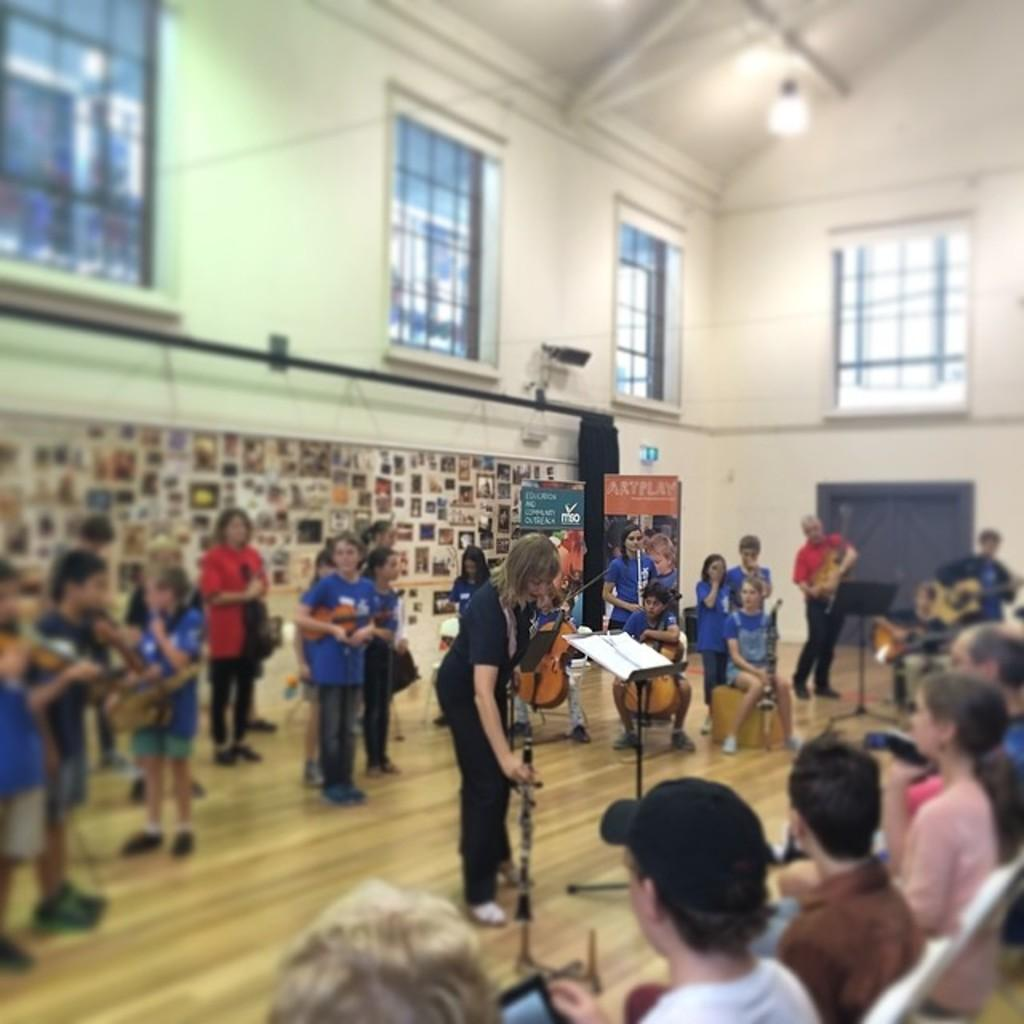How many persons are in the image? There are persons in the image. What are the persons holding in the image? The persons are holding musical instruments. Can you describe the floor in the image? The image shows a floor. What type of objects can be seen in the background of the image? There are frames, a wall, windows, a door, boards, and a light observable in the background. What type of shade is being provided by the snake in the image? There is no snake present in the image, so no shade is being provided by a snake. How many people believe in the power of the boards in the image? The image does not provide information about people's beliefs, so it cannot be determined how many people believe in the power of the boards. 